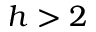Convert formula to latex. <formula><loc_0><loc_0><loc_500><loc_500>h > 2</formula> 